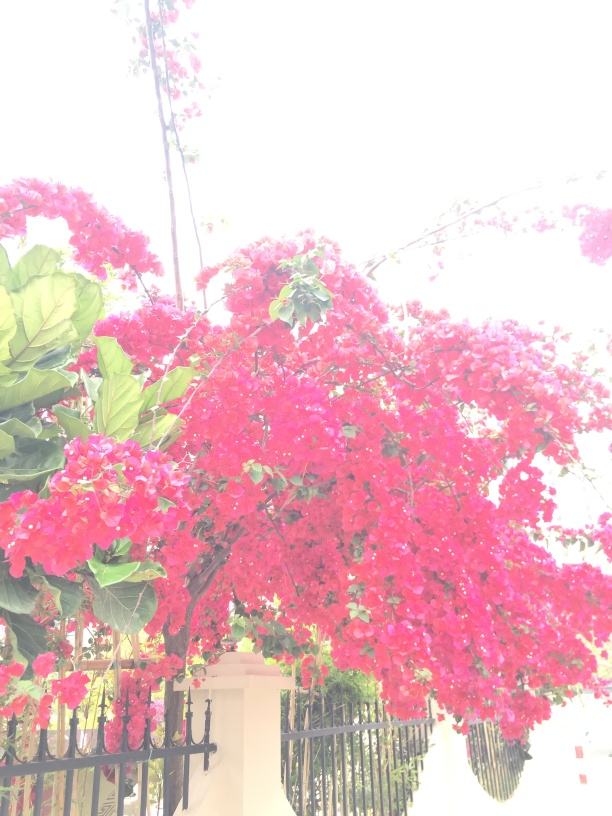What does the setting of this image suggest about the location? The lush Bougainvillea and the bright, sunny environment suggest a location that experiences warm, possibly tropical conditions. The architectural elements visible in the background, like the gate and building style, could hint at a residential area, perhaps in a region where flowering vines like these are common. 